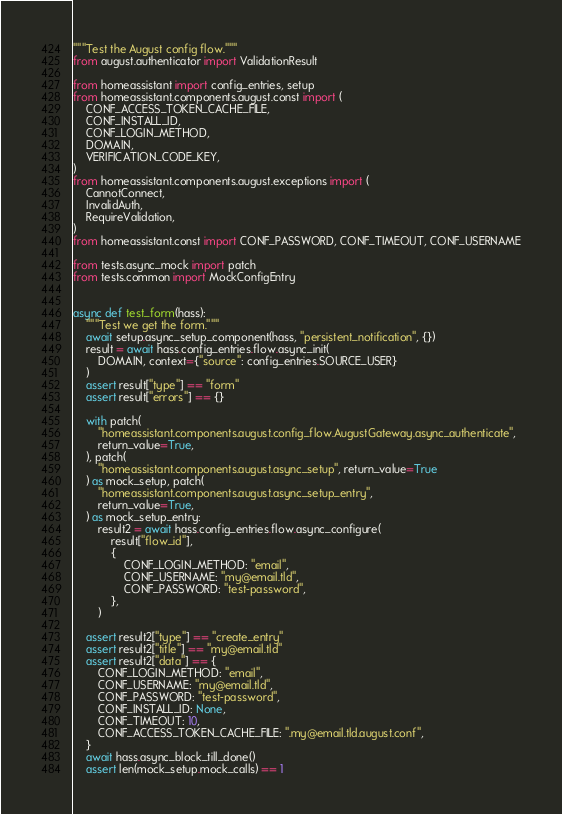<code> <loc_0><loc_0><loc_500><loc_500><_Python_>"""Test the August config flow."""
from august.authenticator import ValidationResult

from homeassistant import config_entries, setup
from homeassistant.components.august.const import (
    CONF_ACCESS_TOKEN_CACHE_FILE,
    CONF_INSTALL_ID,
    CONF_LOGIN_METHOD,
    DOMAIN,
    VERIFICATION_CODE_KEY,
)
from homeassistant.components.august.exceptions import (
    CannotConnect,
    InvalidAuth,
    RequireValidation,
)
from homeassistant.const import CONF_PASSWORD, CONF_TIMEOUT, CONF_USERNAME

from tests.async_mock import patch
from tests.common import MockConfigEntry


async def test_form(hass):
    """Test we get the form."""
    await setup.async_setup_component(hass, "persistent_notification", {})
    result = await hass.config_entries.flow.async_init(
        DOMAIN, context={"source": config_entries.SOURCE_USER}
    )
    assert result["type"] == "form"
    assert result["errors"] == {}

    with patch(
        "homeassistant.components.august.config_flow.AugustGateway.async_authenticate",
        return_value=True,
    ), patch(
        "homeassistant.components.august.async_setup", return_value=True
    ) as mock_setup, patch(
        "homeassistant.components.august.async_setup_entry",
        return_value=True,
    ) as mock_setup_entry:
        result2 = await hass.config_entries.flow.async_configure(
            result["flow_id"],
            {
                CONF_LOGIN_METHOD: "email",
                CONF_USERNAME: "my@email.tld",
                CONF_PASSWORD: "test-password",
            },
        )

    assert result2["type"] == "create_entry"
    assert result2["title"] == "my@email.tld"
    assert result2["data"] == {
        CONF_LOGIN_METHOD: "email",
        CONF_USERNAME: "my@email.tld",
        CONF_PASSWORD: "test-password",
        CONF_INSTALL_ID: None,
        CONF_TIMEOUT: 10,
        CONF_ACCESS_TOKEN_CACHE_FILE: ".my@email.tld.august.conf",
    }
    await hass.async_block_till_done()
    assert len(mock_setup.mock_calls) == 1</code> 